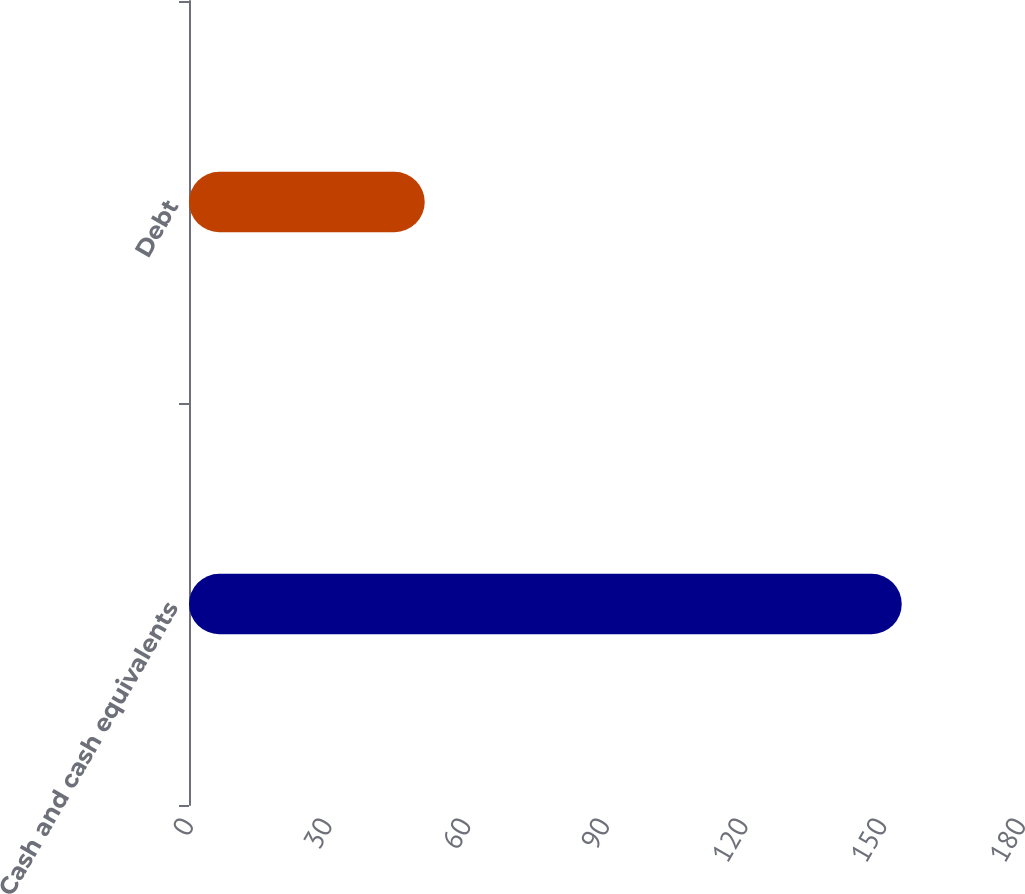Convert chart. <chart><loc_0><loc_0><loc_500><loc_500><bar_chart><fcel>Cash and cash equivalents<fcel>Debt<nl><fcel>154.2<fcel>51<nl></chart> 